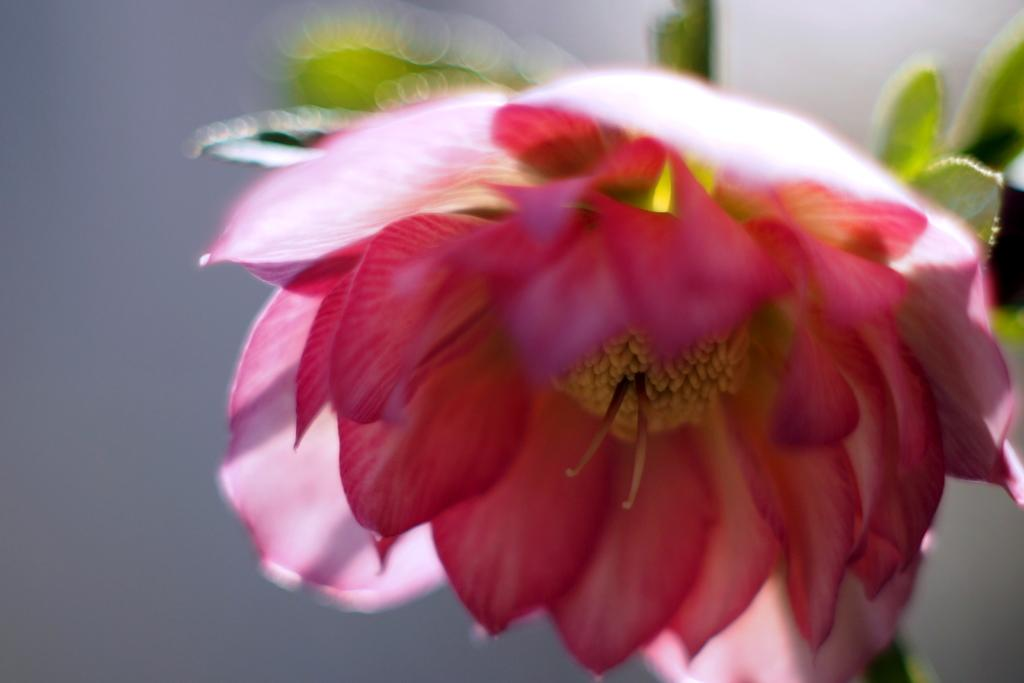What type of flower is in the image? There is a pink flower in the image. Can you describe the background of the image? The background of the image is blurry. How many verses can be seen in the image? There are no verses present in the image; it features a pink flower and a blurry background. 